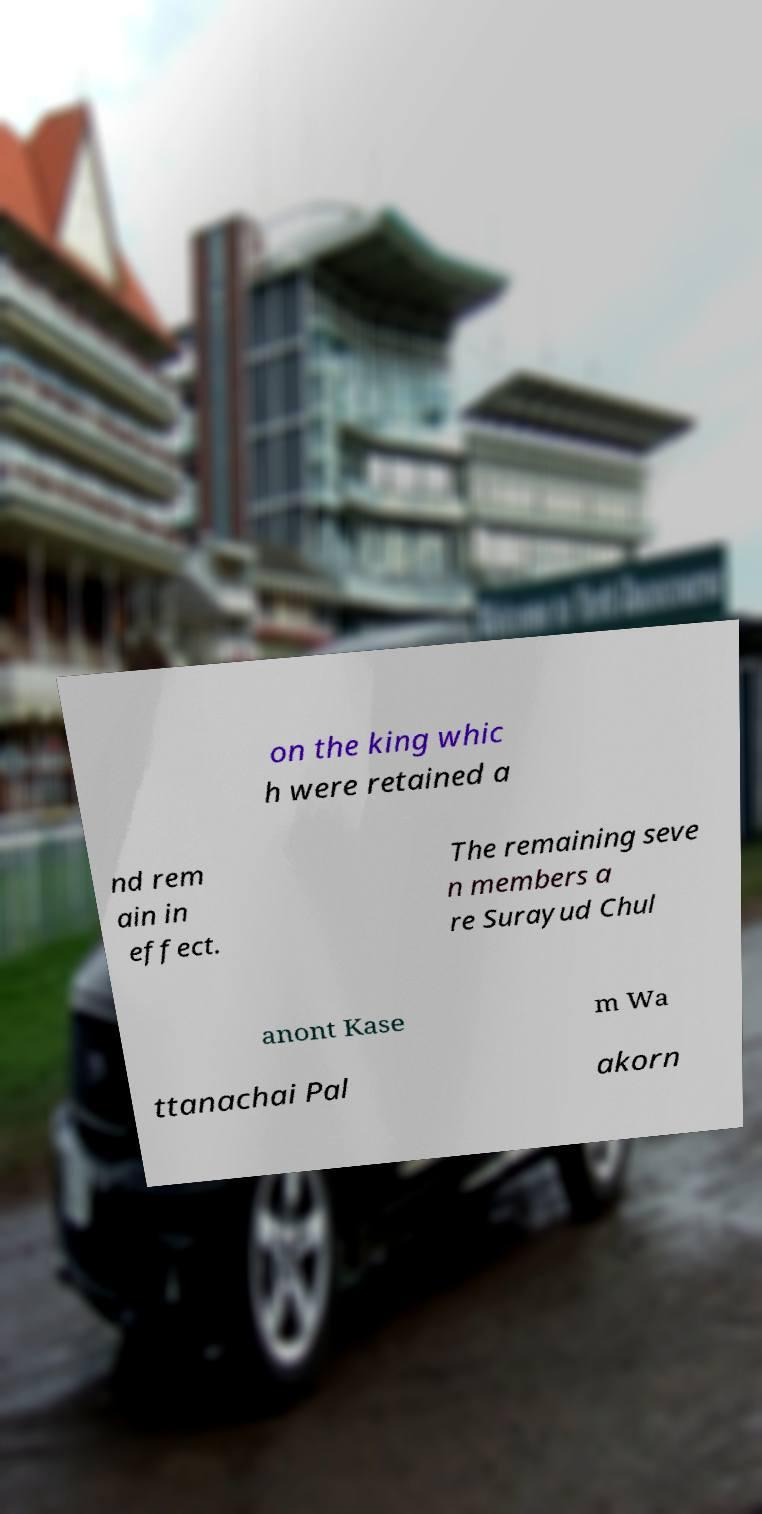There's text embedded in this image that I need extracted. Can you transcribe it verbatim? on the king whic h were retained a nd rem ain in effect. The remaining seve n members a re Surayud Chul anont Kase m Wa ttanachai Pal akorn 